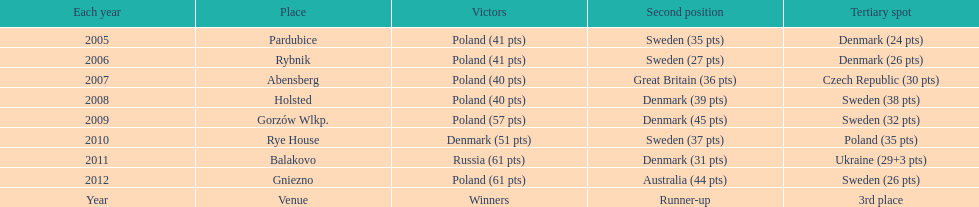Previous to 2008 how many times was sweden the runner up? 2. 